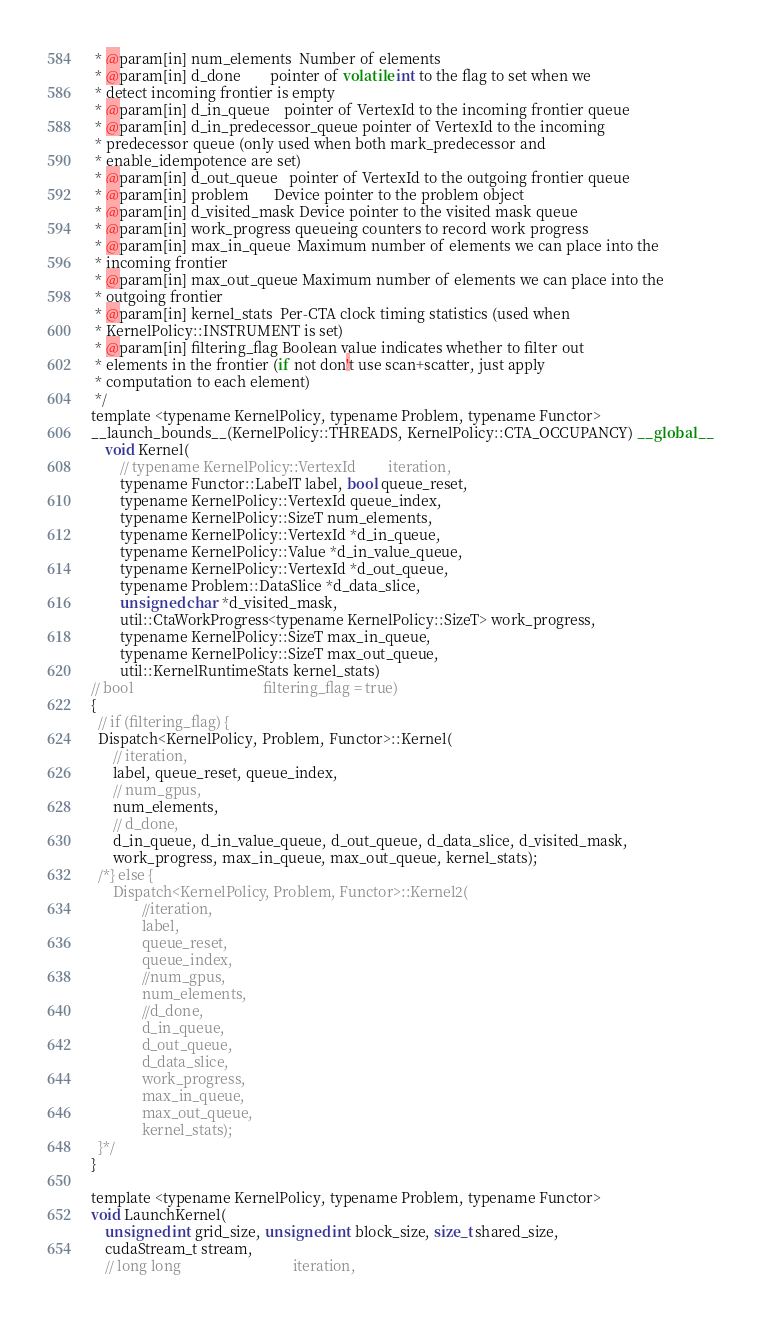Convert code to text. <code><loc_0><loc_0><loc_500><loc_500><_Cuda_> * @param[in] num_elements  Number of elements
 * @param[in] d_done        pointer of volatile int to the flag to set when we
 * detect incoming frontier is empty
 * @param[in] d_in_queue    pointer of VertexId to the incoming frontier queue
 * @param[in] d_in_predecessor_queue pointer of VertexId to the incoming
 * predecessor queue (only used when both mark_predecessor and
 * enable_idempotence are set)
 * @param[in] d_out_queue   pointer of VertexId to the outgoing frontier queue
 * @param[in] problem       Device pointer to the problem object
 * @param[in] d_visited_mask Device pointer to the visited mask queue
 * @param[in] work_progress queueing counters to record work progress
 * @param[in] max_in_queue  Maximum number of elements we can place into the
 * incoming frontier
 * @param[in] max_out_queue Maximum number of elements we can place into the
 * outgoing frontier
 * @param[in] kernel_stats  Per-CTA clock timing statistics (used when
 * KernelPolicy::INSTRUMENT is set)
 * @param[in] filtering_flag Boolean value indicates whether to filter out
 * elements in the frontier (if not don't use scan+scatter, just apply
 * computation to each element)
 */
template <typename KernelPolicy, typename Problem, typename Functor>
__launch_bounds__(KernelPolicy::THREADS, KernelPolicy::CTA_OCCUPANCY) __global__
    void Kernel(
        // typename KernelPolicy::VertexId         iteration,
        typename Functor::LabelT label, bool queue_reset,
        typename KernelPolicy::VertexId queue_index,
        typename KernelPolicy::SizeT num_elements,
        typename KernelPolicy::VertexId *d_in_queue,
        typename KernelPolicy::Value *d_in_value_queue,
        typename KernelPolicy::VertexId *d_out_queue,
        typename Problem::DataSlice *d_data_slice,
        unsigned char *d_visited_mask,
        util::CtaWorkProgress<typename KernelPolicy::SizeT> work_progress,
        typename KernelPolicy::SizeT max_in_queue,
        typename KernelPolicy::SizeT max_out_queue,
        util::KernelRuntimeStats kernel_stats)
// bool                                    filtering_flag = true)
{
  // if (filtering_flag) {
  Dispatch<KernelPolicy, Problem, Functor>::Kernel(
      // iteration,
      label, queue_reset, queue_index,
      // num_gpus,
      num_elements,
      // d_done,
      d_in_queue, d_in_value_queue, d_out_queue, d_data_slice, d_visited_mask,
      work_progress, max_in_queue, max_out_queue, kernel_stats);
  /*} else {
      Dispatch<KernelPolicy, Problem, Functor>::Kernel2(
              //iteration,
              label,
              queue_reset,
              queue_index,
              //num_gpus,
              num_elements,
              //d_done,
              d_in_queue,
              d_out_queue,
              d_data_slice,
              work_progress,
              max_in_queue,
              max_out_queue,
              kernel_stats);
  }*/
}

template <typename KernelPolicy, typename Problem, typename Functor>
void LaunchKernel(
    unsigned int grid_size, unsigned int block_size, size_t shared_size,
    cudaStream_t stream,
    // long long                               iteration,</code> 